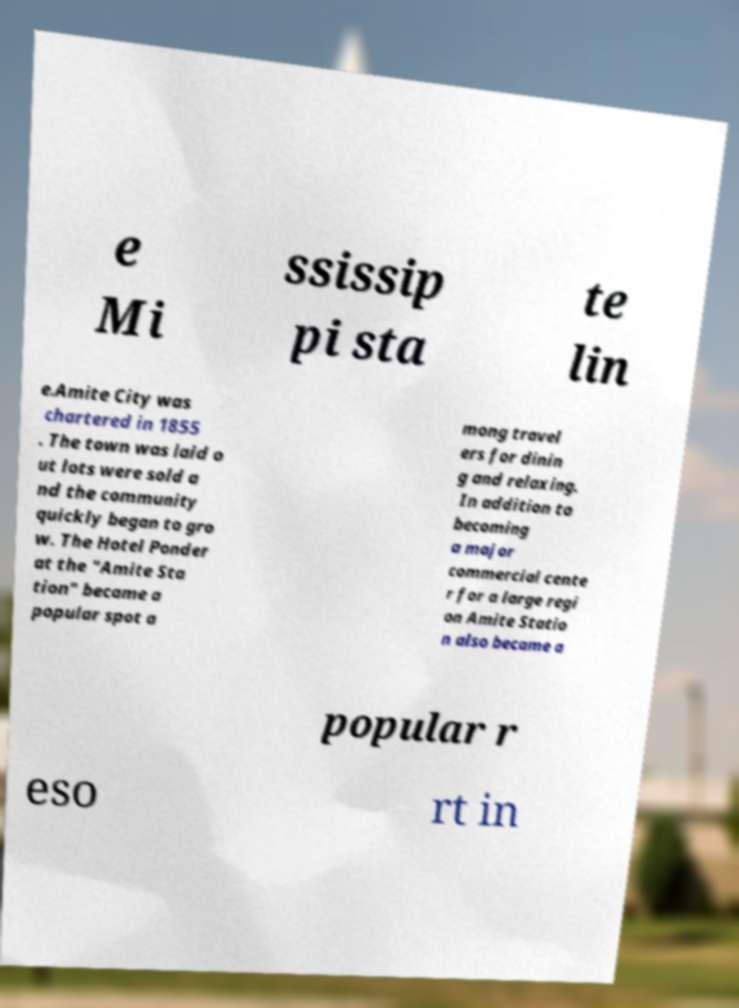I need the written content from this picture converted into text. Can you do that? e Mi ssissip pi sta te lin e.Amite City was chartered in 1855 . The town was laid o ut lots were sold a nd the community quickly began to gro w. The Hotel Ponder at the "Amite Sta tion" became a popular spot a mong travel ers for dinin g and relaxing. In addition to becoming a major commercial cente r for a large regi on Amite Statio n also became a popular r eso rt in 